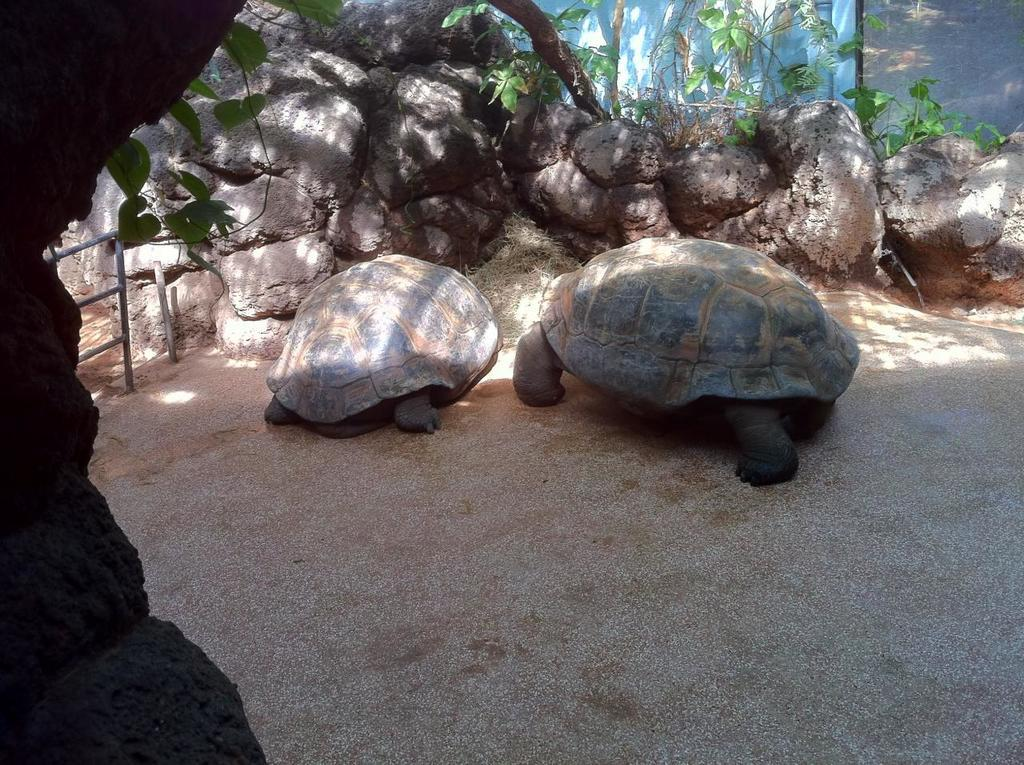How many turtles can be seen in the image? There are two turtles in the image. What type of natural elements are visible in the image? Rocks and trees are present in the image. What type of man-made structures can be seen in the image? A metal rod fence and a wall are visible in the image. Can you describe the location of the tree in the image? There is a tree on the left side of the image. What is the distance between the turtles and the tank in the image? There is no tank present in the image, so it is not possible to determine the distance between the turtles and a tank. 